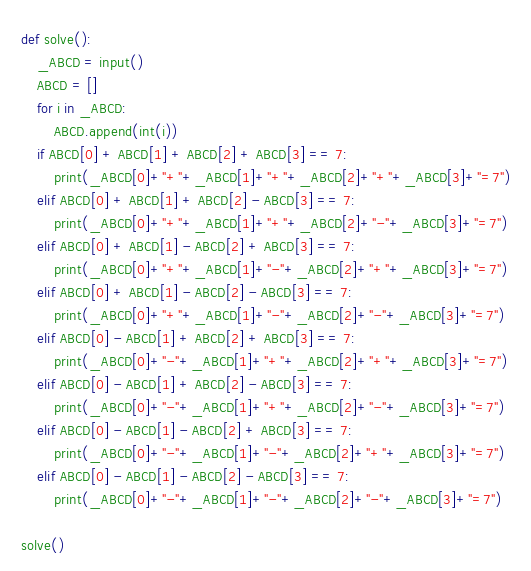Convert code to text. <code><loc_0><loc_0><loc_500><loc_500><_Python_>def solve():
    _ABCD = input()
    ABCD = []
    for i in _ABCD:
        ABCD.append(int(i))
    if ABCD[0] + ABCD[1] + ABCD[2] + ABCD[3] == 7:
        print(_ABCD[0]+"+"+_ABCD[1]+"+"+_ABCD[2]+"+"+_ABCD[3]+"=7")
    elif ABCD[0] + ABCD[1] + ABCD[2] - ABCD[3] == 7:
        print(_ABCD[0]+"+"+_ABCD[1]+"+"+_ABCD[2]+"-"+_ABCD[3]+"=7")
    elif ABCD[0] + ABCD[1] - ABCD[2] + ABCD[3] == 7:
        print(_ABCD[0]+"+"+_ABCD[1]+"-"+_ABCD[2]+"+"+_ABCD[3]+"=7")
    elif ABCD[0] + ABCD[1] - ABCD[2] - ABCD[3] == 7:
        print(_ABCD[0]+"+"+_ABCD[1]+"-"+_ABCD[2]+"-"+_ABCD[3]+"=7")
    elif ABCD[0] - ABCD[1] + ABCD[2] + ABCD[3] == 7:
        print(_ABCD[0]+"-"+_ABCD[1]+"+"+_ABCD[2]+"+"+_ABCD[3]+"=7")
    elif ABCD[0] - ABCD[1] + ABCD[2] - ABCD[3] == 7:
        print(_ABCD[0]+"-"+_ABCD[1]+"+"+_ABCD[2]+"-"+_ABCD[3]+"=7")
    elif ABCD[0] - ABCD[1] - ABCD[2] + ABCD[3] == 7:
        print(_ABCD[0]+"-"+_ABCD[1]+"-"+_ABCD[2]+"+"+_ABCD[3]+"=7")
    elif ABCD[0] - ABCD[1] - ABCD[2] - ABCD[3] == 7:
        print(_ABCD[0]+"-"+_ABCD[1]+"-"+_ABCD[2]+"-"+_ABCD[3]+"=7")

solve()
</code> 